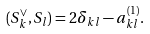<formula> <loc_0><loc_0><loc_500><loc_500>( S _ { k } ^ { \vee } , S _ { l } ) = 2 \delta _ { k l } - a ^ { ( 1 ) } _ { k l } .</formula> 